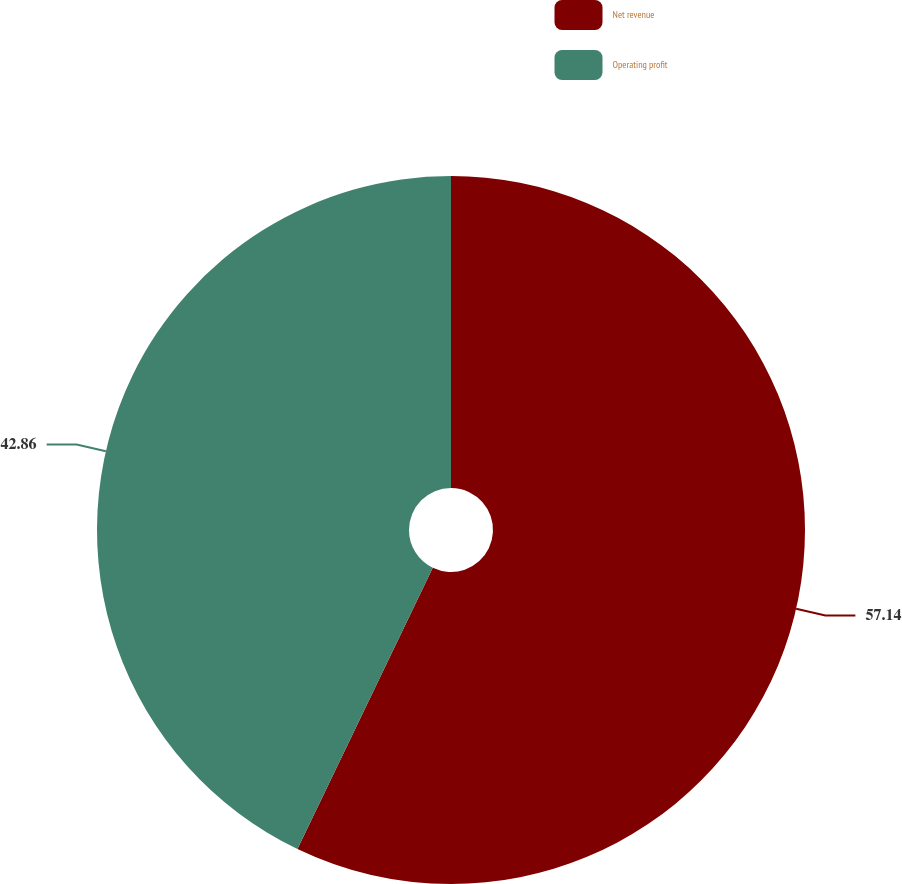Convert chart to OTSL. <chart><loc_0><loc_0><loc_500><loc_500><pie_chart><fcel>Net revenue<fcel>Operating profit<nl><fcel>57.14%<fcel>42.86%<nl></chart> 